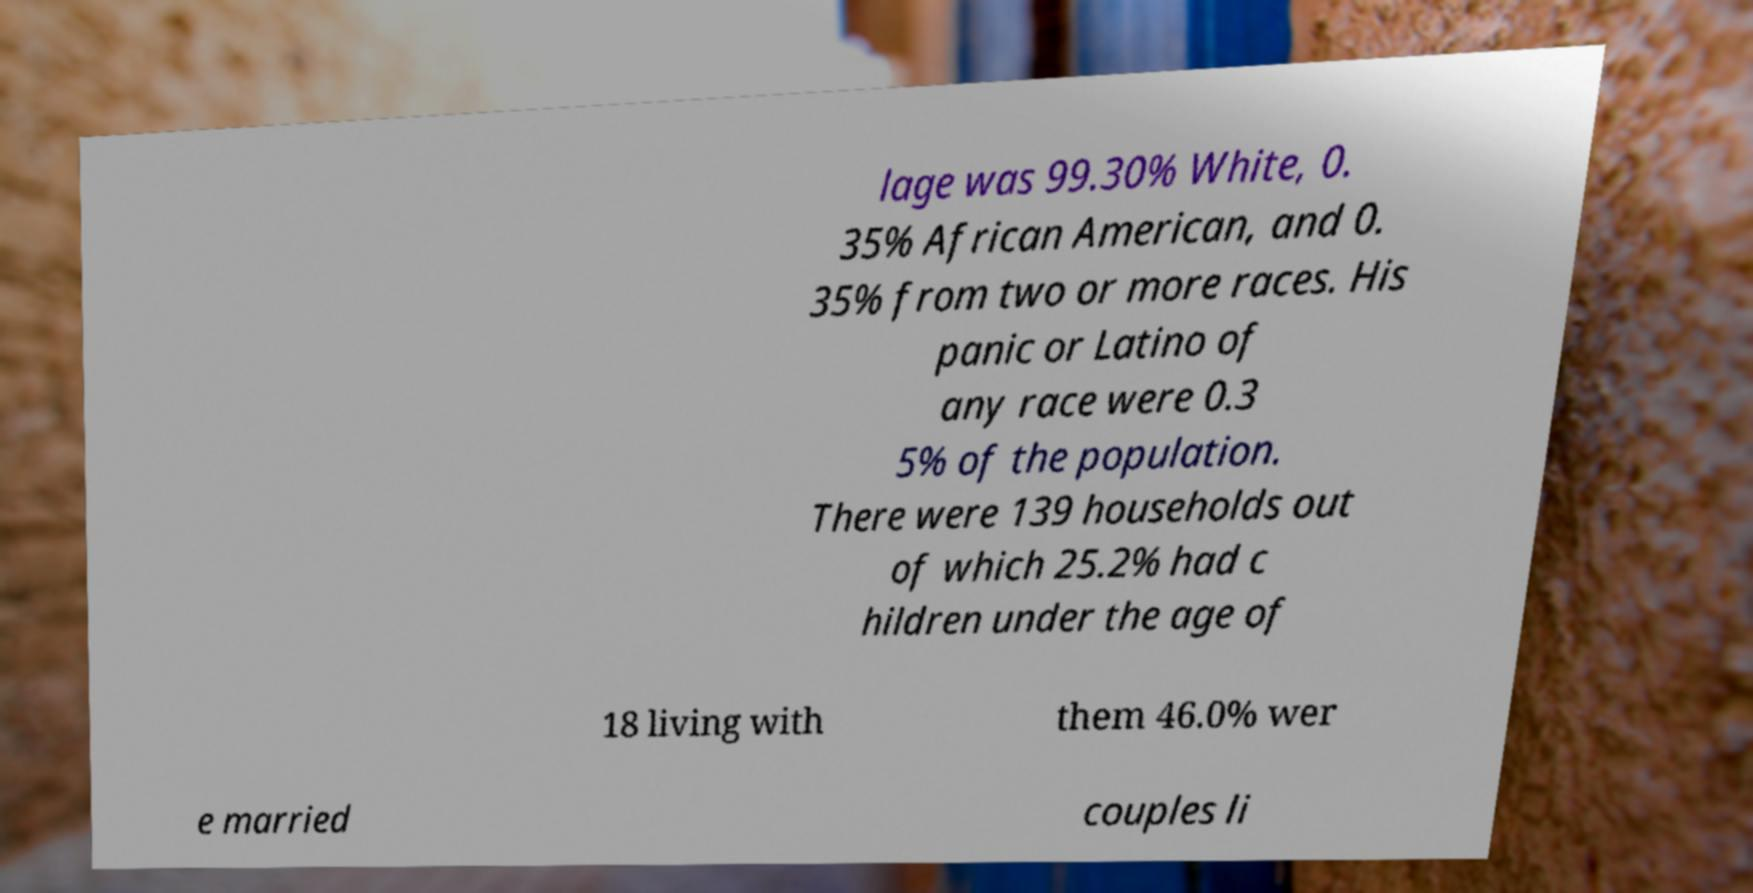Please read and relay the text visible in this image. What does it say? lage was 99.30% White, 0. 35% African American, and 0. 35% from two or more races. His panic or Latino of any race were 0.3 5% of the population. There were 139 households out of which 25.2% had c hildren under the age of 18 living with them 46.0% wer e married couples li 